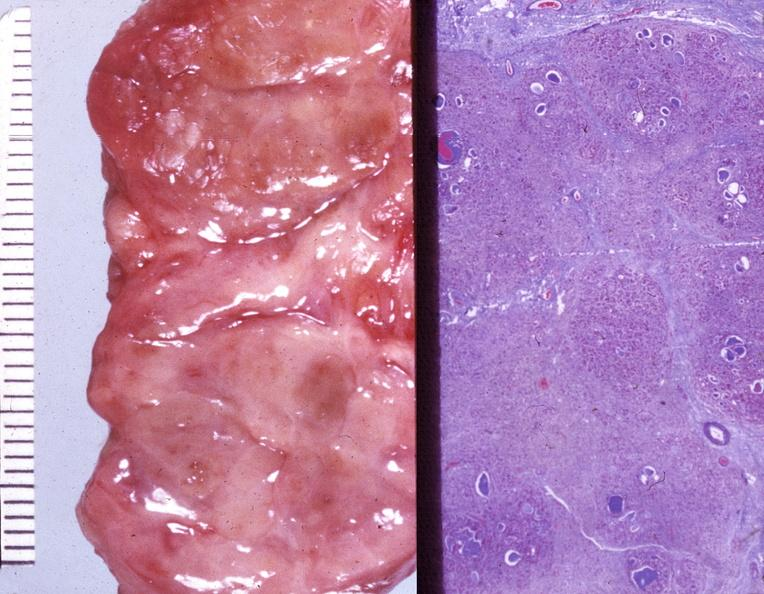what is present?
Answer the question using a single word or phrase. Endocrine 